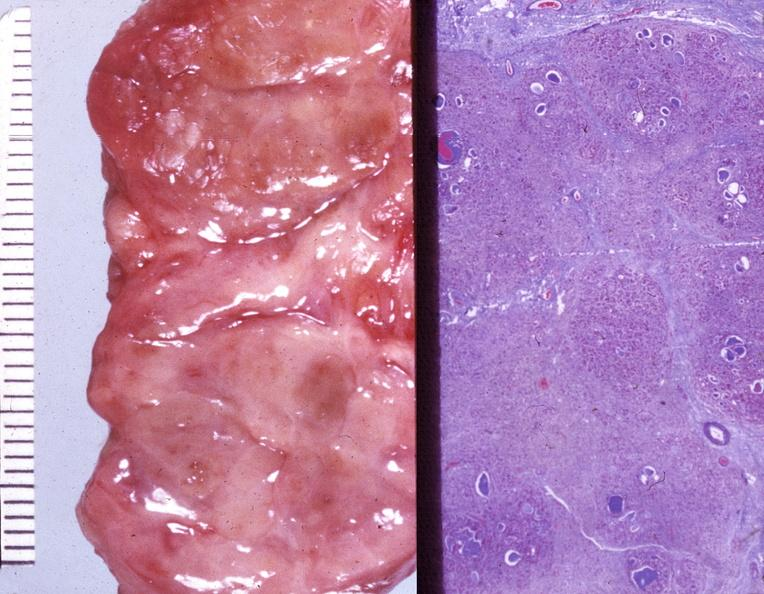what is present?
Answer the question using a single word or phrase. Endocrine 